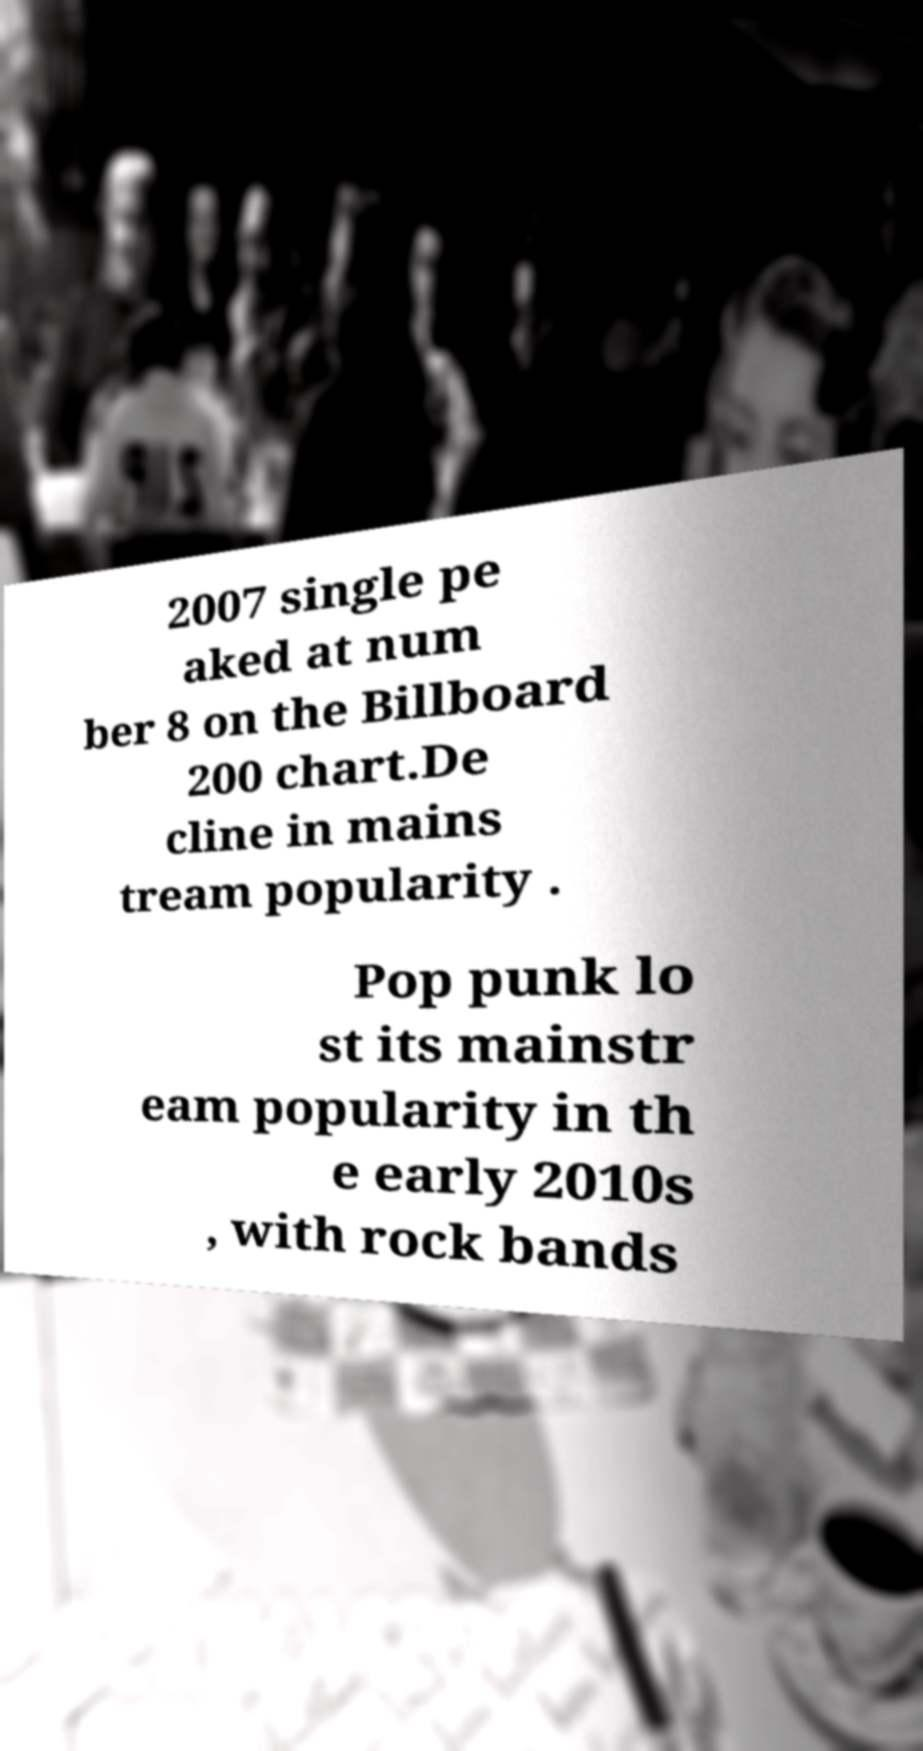Can you read and provide the text displayed in the image?This photo seems to have some interesting text. Can you extract and type it out for me? 2007 single pe aked at num ber 8 on the Billboard 200 chart.De cline in mains tream popularity . Pop punk lo st its mainstr eam popularity in th e early 2010s , with rock bands 